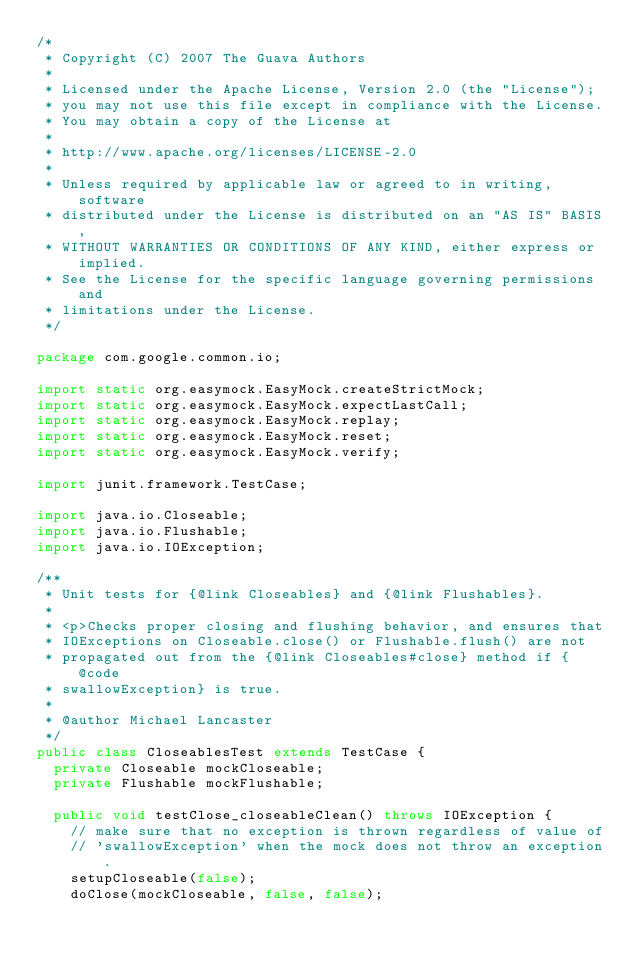<code> <loc_0><loc_0><loc_500><loc_500><_Java_>/*
 * Copyright (C) 2007 The Guava Authors
 *
 * Licensed under the Apache License, Version 2.0 (the "License");
 * you may not use this file except in compliance with the License.
 * You may obtain a copy of the License at
 *
 * http://www.apache.org/licenses/LICENSE-2.0
 *
 * Unless required by applicable law or agreed to in writing, software
 * distributed under the License is distributed on an "AS IS" BASIS,
 * WITHOUT WARRANTIES OR CONDITIONS OF ANY KIND, either express or implied.
 * See the License for the specific language governing permissions and
 * limitations under the License.
 */

package com.google.common.io;

import static org.easymock.EasyMock.createStrictMock;
import static org.easymock.EasyMock.expectLastCall;
import static org.easymock.EasyMock.replay;
import static org.easymock.EasyMock.reset;
import static org.easymock.EasyMock.verify;

import junit.framework.TestCase;

import java.io.Closeable;
import java.io.Flushable;
import java.io.IOException;

/**
 * Unit tests for {@link Closeables} and {@link Flushables}.
 *
 * <p>Checks proper closing and flushing behavior, and ensures that
 * IOExceptions on Closeable.close() or Flushable.flush() are not
 * propagated out from the {@link Closeables#close} method if {@code
 * swallowException} is true.
 *
 * @author Michael Lancaster
 */
public class CloseablesTest extends TestCase {
  private Closeable mockCloseable;
  private Flushable mockFlushable;

  public void testClose_closeableClean() throws IOException {
    // make sure that no exception is thrown regardless of value of
    // 'swallowException' when the mock does not throw an exception.
    setupCloseable(false);
    doClose(mockCloseable, false, false);
</code> 